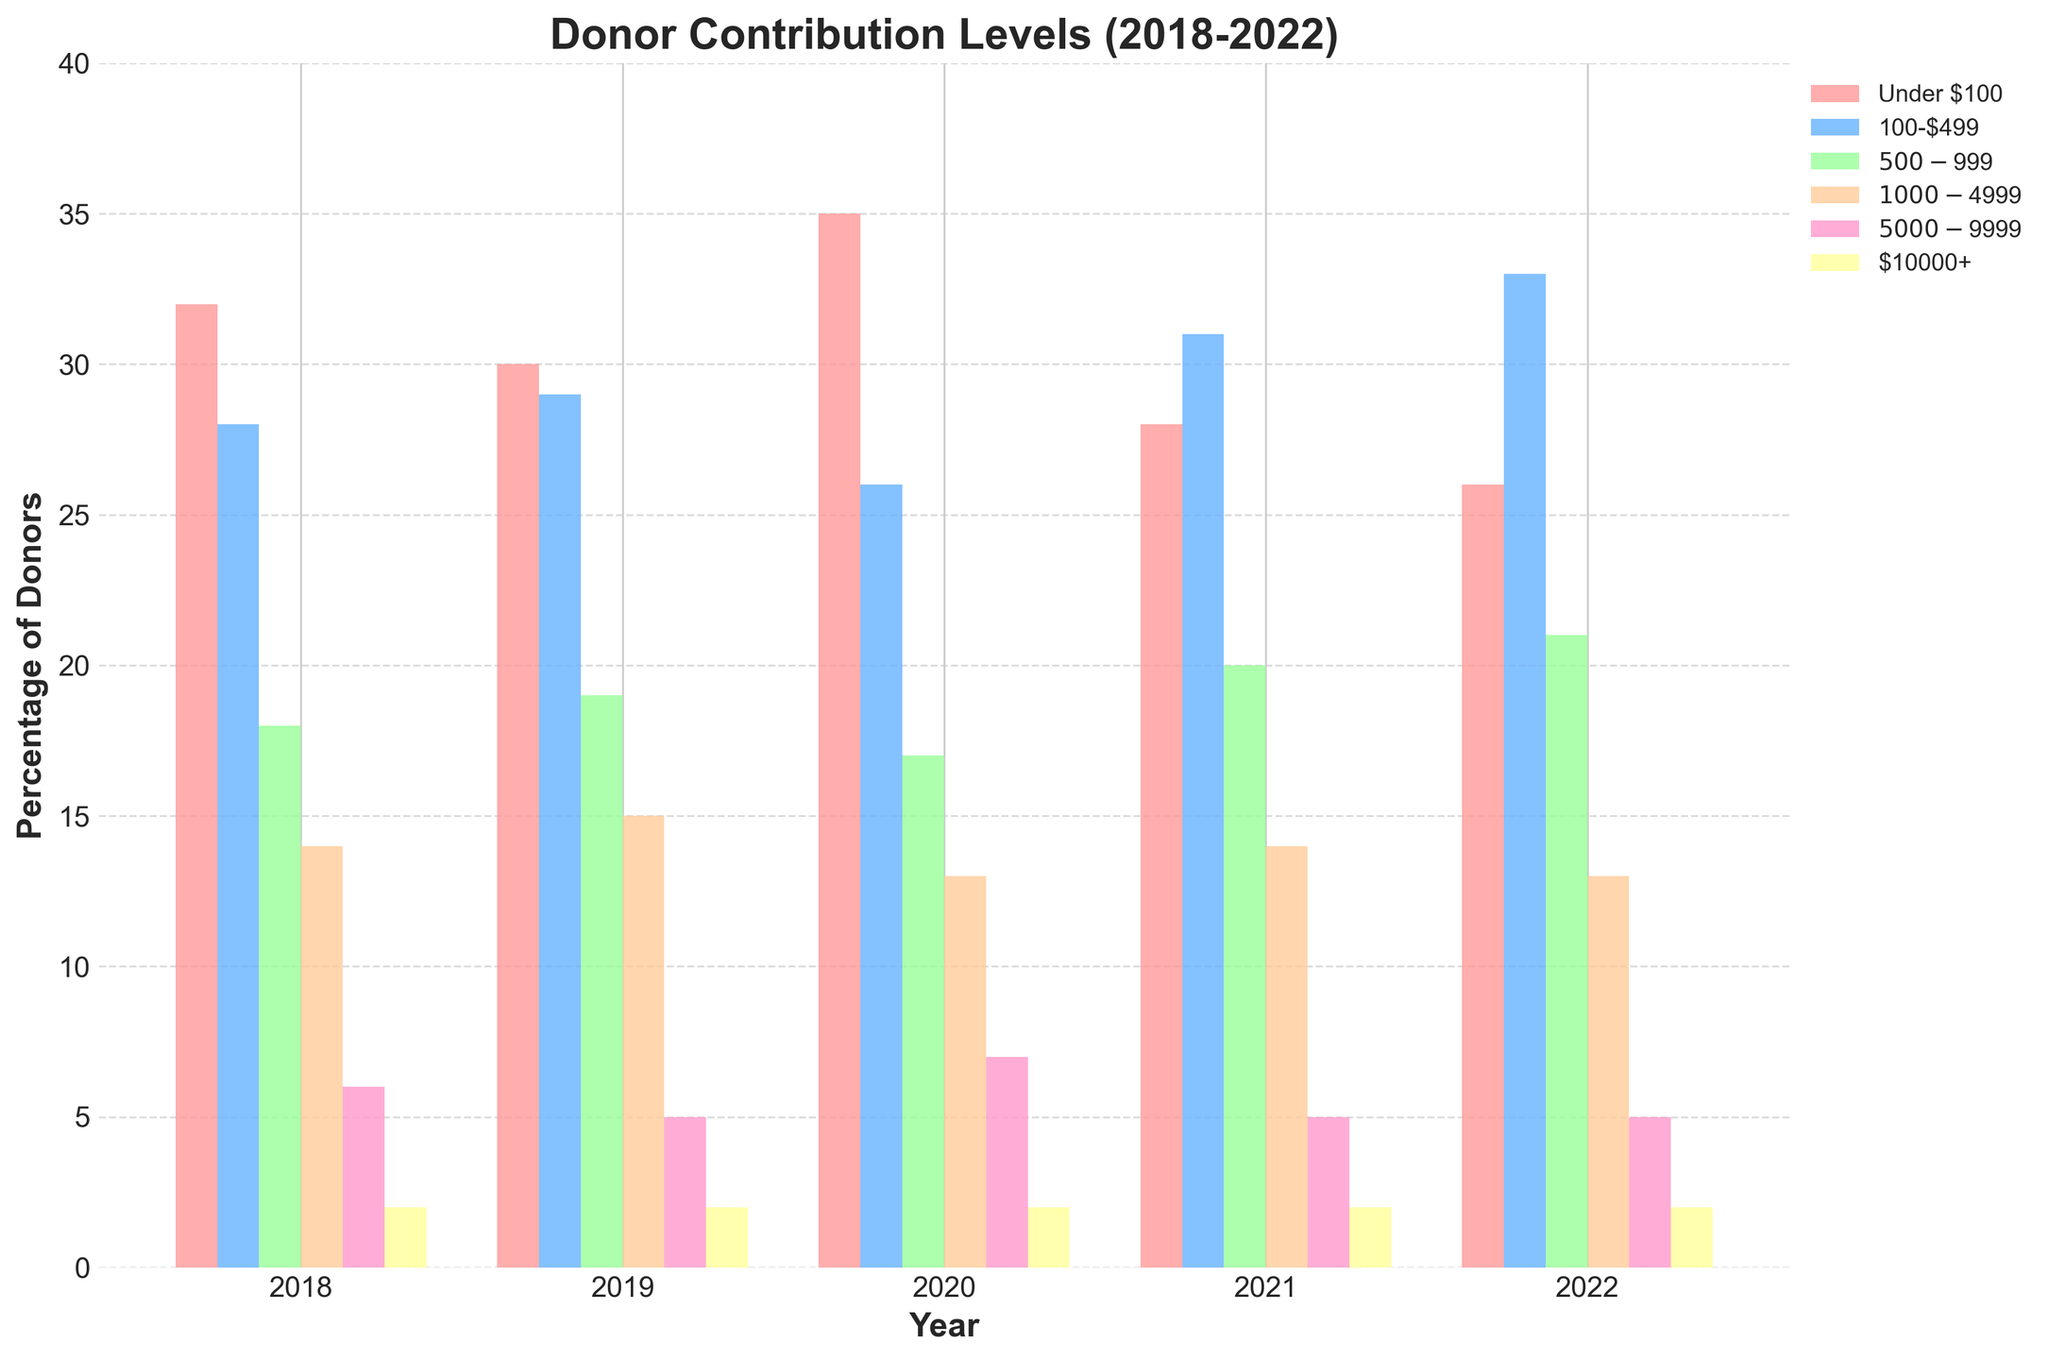What's the percentage change in donors contributing under $100 from 2018 to 2022? To find the percentage change, subtract the percentage for 2022 from the percentage for 2018 and then divide by the percentage for 2018, finally multiply by 100. (32% - 26%) / 32% * 100 = 18.75%
Answer: 18.75% Which year had the highest percentage of donors contributing 100-$499? From the bar chart, we can see that 2022 had the highest percentage of donors in the 100-$499 category, marked by the height of the green bar.
Answer: 2022 Compare the percentage of donors contributing $1000-$4999 in 2018 and 2021. Which year had a higher percentage and by how much? Looking at the heights of the orange bars, the percentage for 2018 is 14% and for 2021 it is also 14%. So, the difference is 0%.
Answer: Both years are equal What was the combined percentage of donors contributing $500-$999 and $10000+ in 2019? Add the percentages for these categories in 2019: 19% (for $500-$999) + 2% (for $10000+). 19% + 2% = 21%.
Answer: 21% In which year did the $5000-$9999 contribution level see its highest percentage, and what was that percentage? By examining the purple bars, 2020 had the highest percentage for this level, marked at 7%.
Answer: 2020, 7% Which contribution level showed the most consistent percentage across the years 2018-2022? By observing the bars and their heights, the $10000+ contribution level shows a consistent percentage of 2% across all years.
Answer: $10000+ What was the difference in percentage of donors contributing under $100 between 2020 and 2021? From the blue bars, the values are 35% (2020) and 28% (2021). The difference is 35% - 28% = 7%.
Answer: 7% What's the average percentage of donors contributing $500-$999 across the 5 years? Add the percentages for these years and divide by 5: (18% + 19% + 17% + 20% + 21%) / 5. The sum is 95%, so the average is 95% / 5 = 19%.
Answer: 19% Which year had the lowest overall percentage of donors contributing $5000-$9999, and what was it? By examining the purple bars, the lowest percentage is for 2019 and 2021, both marked at 5%.
Answer: 2019 and 2021, 5% Was there a year where the percentage of donors contributing under $100 was equal to those contributing $500-$999? No such year has equal percentages when comparing the blue bars for under $100 and the yellow bars for $500-$999.
Answer: No 